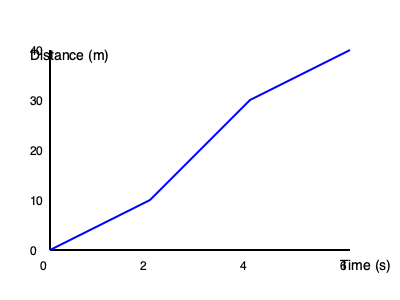As a software engineer working on a Flex-based data visualization project, you need to calculate the velocity of an object from a distance-time graph. Given the graph above, determine the average velocity of the object between $t=2s$ and $t=4s$. To calculate the average velocity, we'll use the formula:

$$ v_{avg} = \frac{\Delta d}{\Delta t} $$

Where $\Delta d$ is the change in distance and $\Delta t$ is the change in time.

Steps:
1. Identify the distances at $t=2s$ and $t=4s$:
   - At $t=2s$, $d_1 = 10m$
   - At $t=4s$, $d_2 = 30m$

2. Calculate $\Delta d$:
   $$ \Delta d = d_2 - d_1 = 30m - 10m = 20m $$

3. Calculate $\Delta t$:
   $$ \Delta t = 4s - 2s = 2s $$

4. Apply the average velocity formula:
   $$ v_{avg} = \frac{\Delta d}{\Delta t} = \frac{20m}{2s} = 10 m/s $$

Therefore, the average velocity between $t=2s$ and $t=4s$ is $10 m/s$.
Answer: $10 m/s$ 